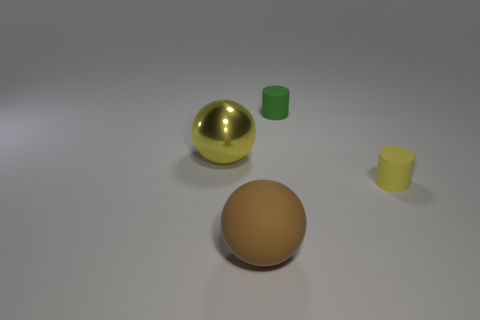What is the shape of the object that is the same color as the metallic sphere?
Ensure brevity in your answer.  Cylinder. How many cylinders are made of the same material as the small green object?
Your answer should be compact. 1. What is the color of the large thing that is made of the same material as the tiny yellow thing?
Give a very brief answer. Brown. Do the yellow cylinder and the object that is behind the large yellow sphere have the same size?
Provide a succinct answer. Yes. The yellow thing on the left side of the green cylinder right of the ball that is on the right side of the metallic thing is made of what material?
Your response must be concise. Metal. What number of things are large metal balls or spheres?
Keep it short and to the point. 2. Do the small rubber thing behind the large yellow metal object and the tiny object to the right of the green cylinder have the same color?
Provide a short and direct response. No. What shape is the yellow rubber thing that is the same size as the green matte object?
Your response must be concise. Cylinder. How many things are either small rubber cylinders left of the yellow rubber cylinder or large things on the left side of the big rubber sphere?
Give a very brief answer. 2. Is the number of tiny matte objects less than the number of big yellow metallic things?
Give a very brief answer. No. 